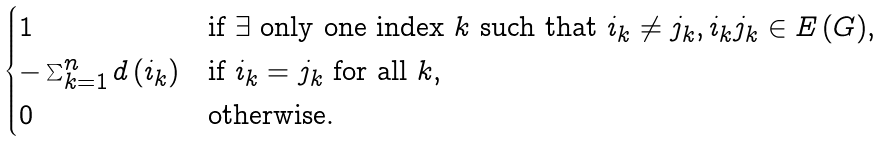Convert formula to latex. <formula><loc_0><loc_0><loc_500><loc_500>\begin{cases} 1 & \text {if $\exists$ only one index $k$ such that $i_{k}\neq j_{k},i_{k}j_{k}\in E\left( G\right)$} , \\ - \sum _ { k = 1 } ^ { n } d \left ( i _ { k } \right ) & \text {if $i_{k}=j_{k}$ for all $k$} , \\ 0 & \text {otherwise.} \end{cases}</formula> 